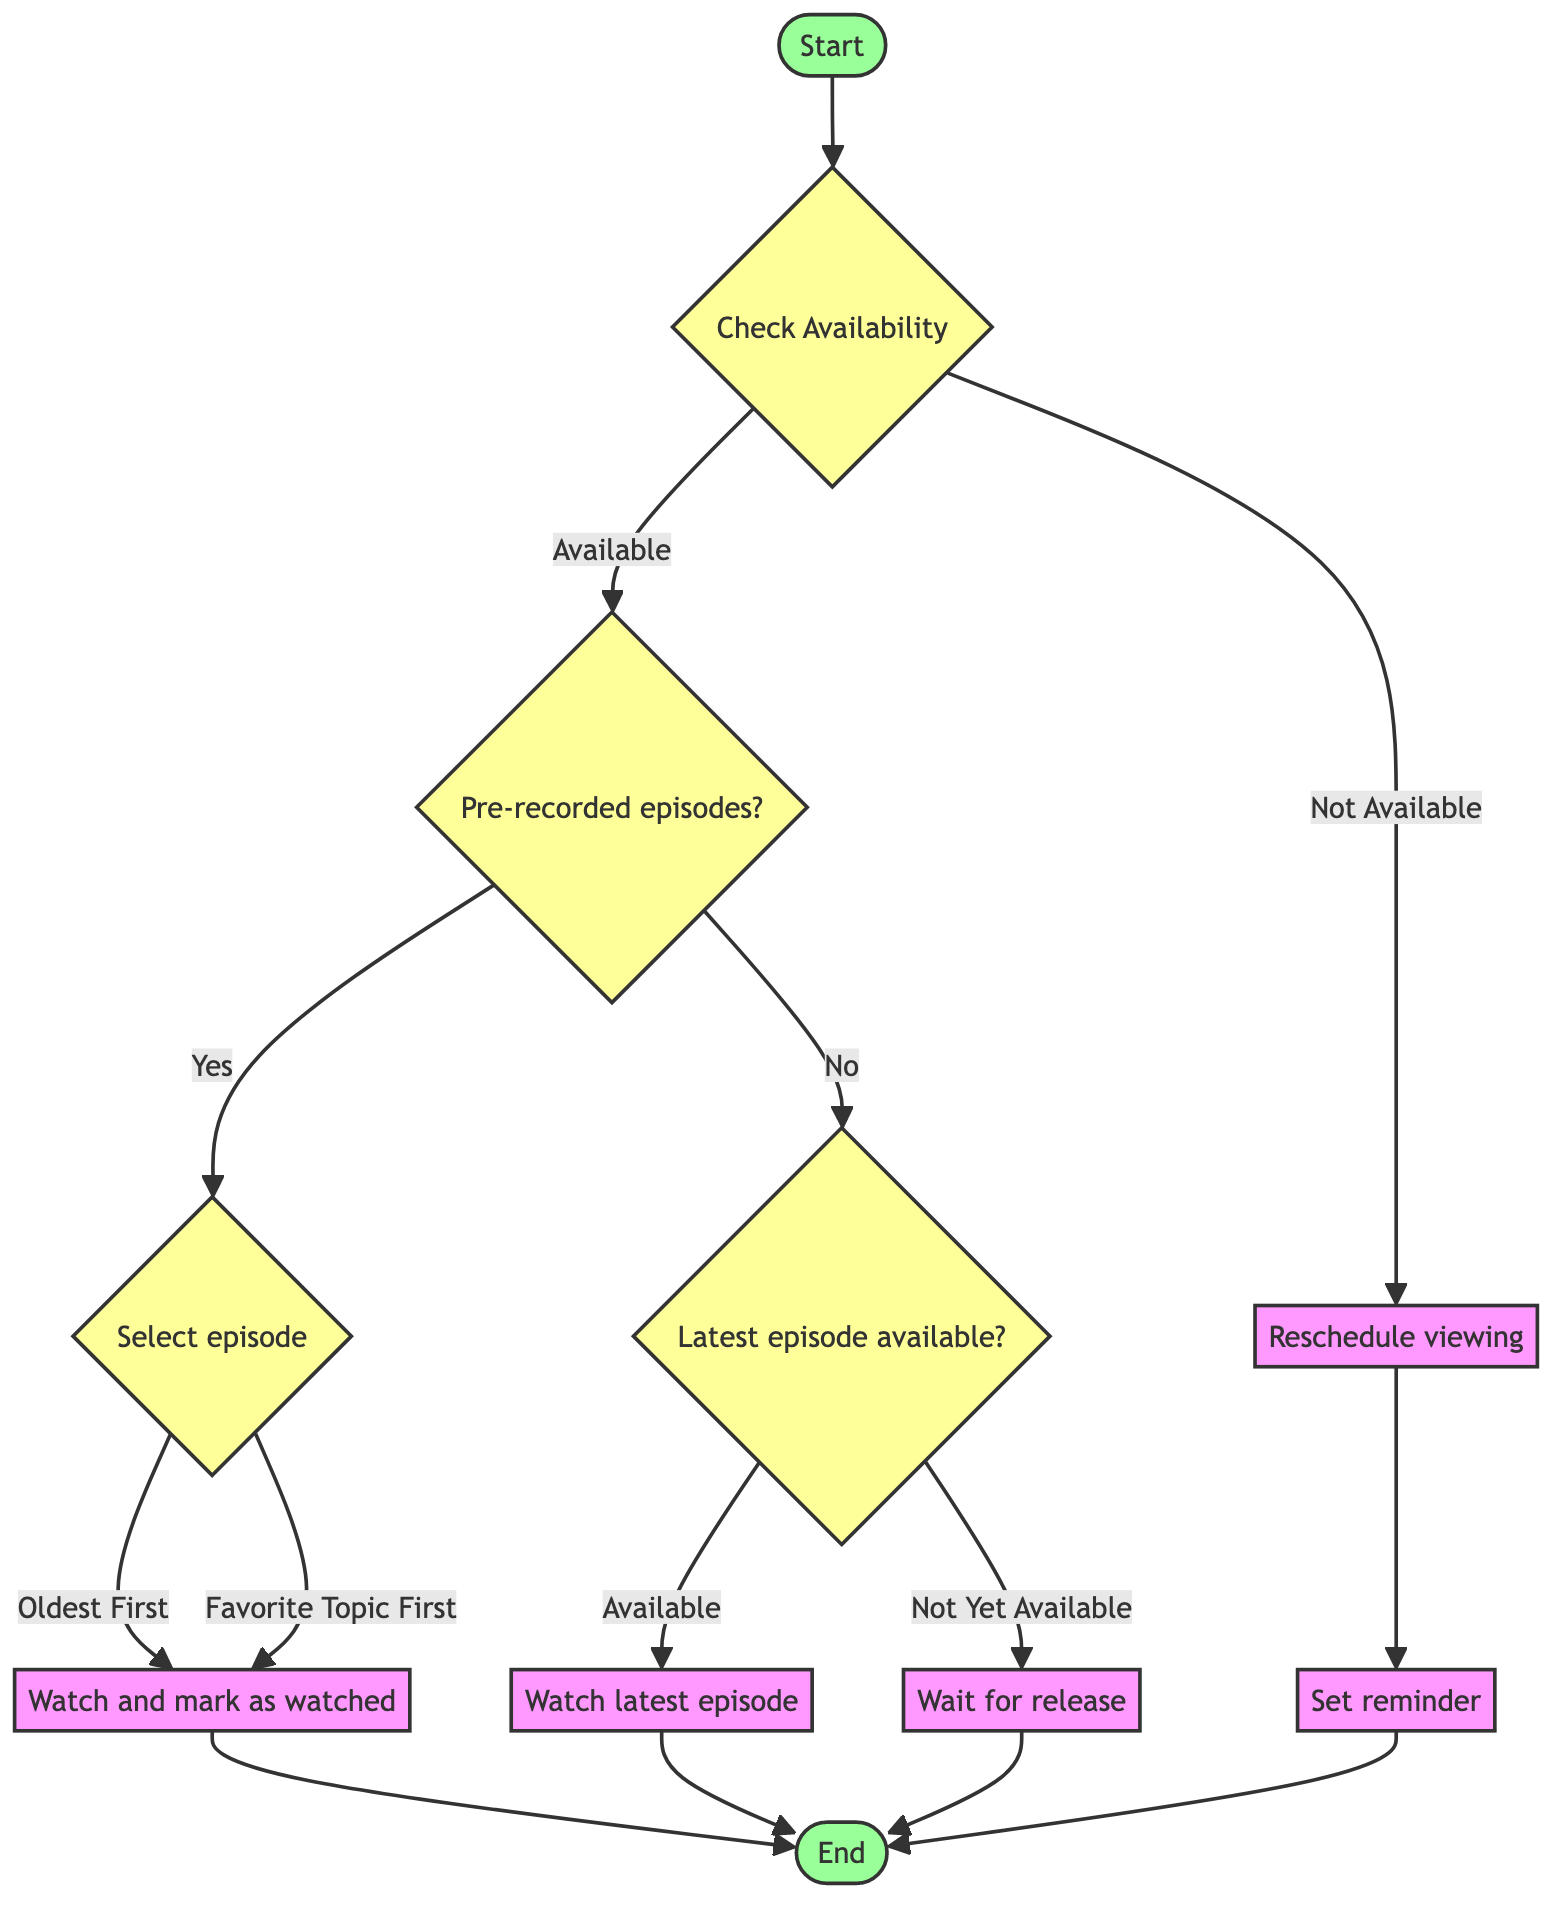What is the first step in the flowchart? The first step in the flowchart is labeled "Start," indicating the initial point of the process before any evaluations or actions are taken.
Answer: Start How many decision nodes are present in the diagram? There are five decision nodes in the diagram: "Check Availability," "Pre-recorded episodes?," "Select episode," "Latest episode available?," and "Reschedule viewing."
Answer: 5 What happens if you are not available to watch? If you are not available, the flowchart directs you to "Reschedule Watching," indicating you should find a more convenient time to watch instead of proceeding to watch an episode.
Answer: Reschedule Watching If you have a backlog of episodes, what option do you have for selecting an episode? The available options are "Oldest First" and "Favorite Topic First," specifying two ways to prioritize episodes when watching from the backlog.
Answer: Oldest First or Favorite Topic First What action is taken after watching the latest episode? After watching the latest episode, the flowchart leads to "End," indicating the conclusion of the viewing process.
Answer: End If there are no pre-recorded episodes, what is the next step? If there are no pre-recorded episodes, the next step is to "Check Current Latest Episode" to see if the most recent episode is available for viewing.
Answer: Check Current Latest Episode What does the "Set Reminder" step indicate? The "Set Reminder" step indicates that if you choose to reschedule watching, you should set a reminder for the next available time slot to watch John Oliver.
Answer: Set Reminder What is the outcome if the latest episode is not yet available? If the latest episode is not yet available, the flowchart directs you to "Wait For Release," indicating you must be patient until the episode is released.
Answer: Wait For Release 